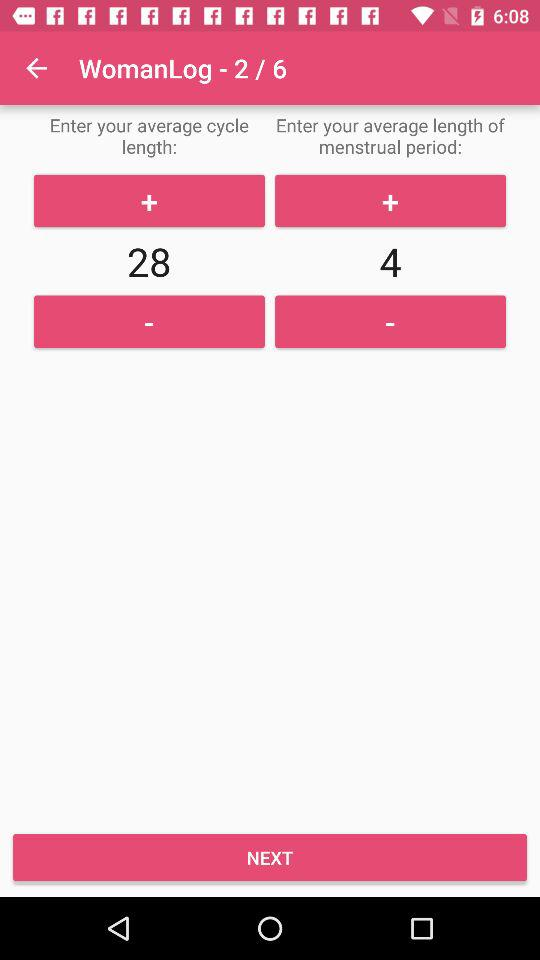On what slide are we currently? You are currently on slide 2. 